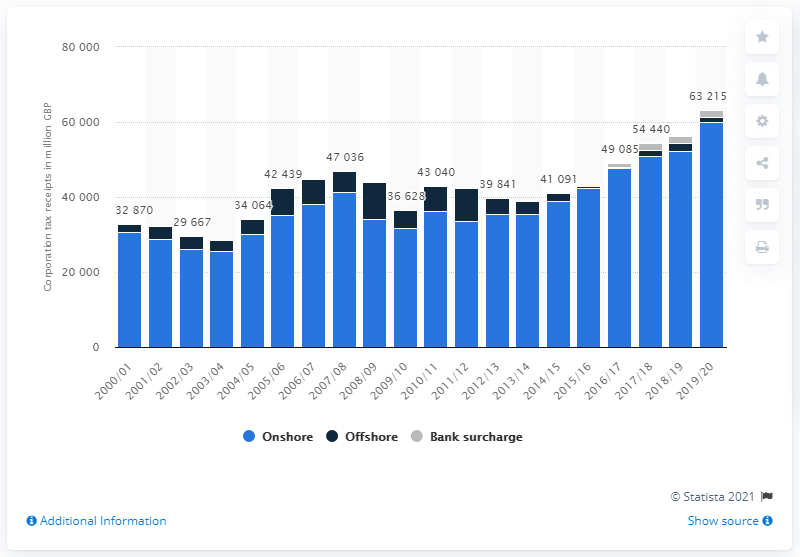Highlight a few significant elements in this photo. In 2019/20, the amount of onshore corporation tax receipts was 59,954. 